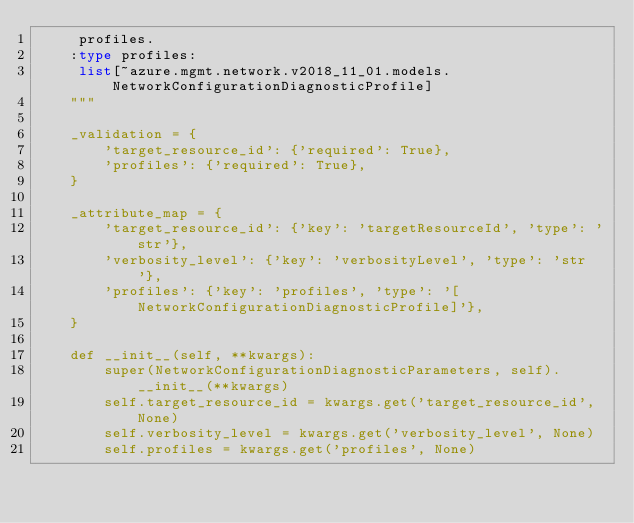<code> <loc_0><loc_0><loc_500><loc_500><_Python_>     profiles.
    :type profiles:
     list[~azure.mgmt.network.v2018_11_01.models.NetworkConfigurationDiagnosticProfile]
    """

    _validation = {
        'target_resource_id': {'required': True},
        'profiles': {'required': True},
    }

    _attribute_map = {
        'target_resource_id': {'key': 'targetResourceId', 'type': 'str'},
        'verbosity_level': {'key': 'verbosityLevel', 'type': 'str'},
        'profiles': {'key': 'profiles', 'type': '[NetworkConfigurationDiagnosticProfile]'},
    }

    def __init__(self, **kwargs):
        super(NetworkConfigurationDiagnosticParameters, self).__init__(**kwargs)
        self.target_resource_id = kwargs.get('target_resource_id', None)
        self.verbosity_level = kwargs.get('verbosity_level', None)
        self.profiles = kwargs.get('profiles', None)
</code> 